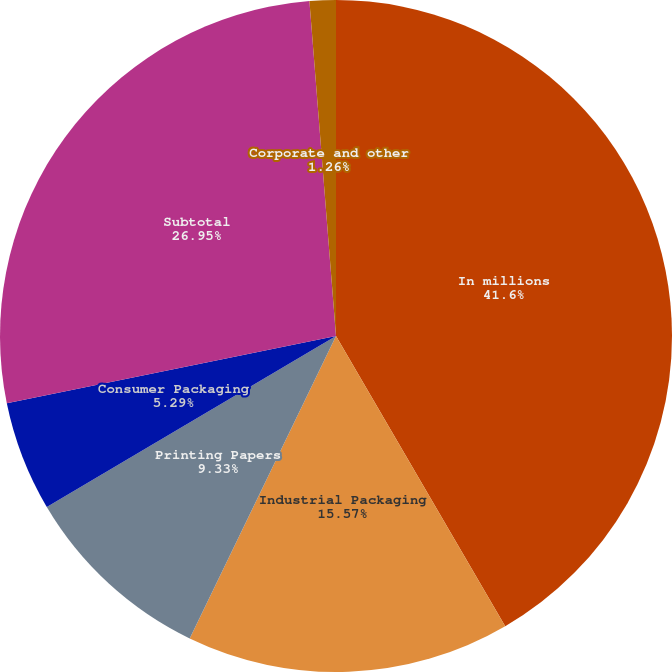Convert chart to OTSL. <chart><loc_0><loc_0><loc_500><loc_500><pie_chart><fcel>In millions<fcel>Industrial Packaging<fcel>Printing Papers<fcel>Consumer Packaging<fcel>Subtotal<fcel>Corporate and other<nl><fcel>41.6%<fcel>15.57%<fcel>9.33%<fcel>5.29%<fcel>26.95%<fcel>1.26%<nl></chart> 